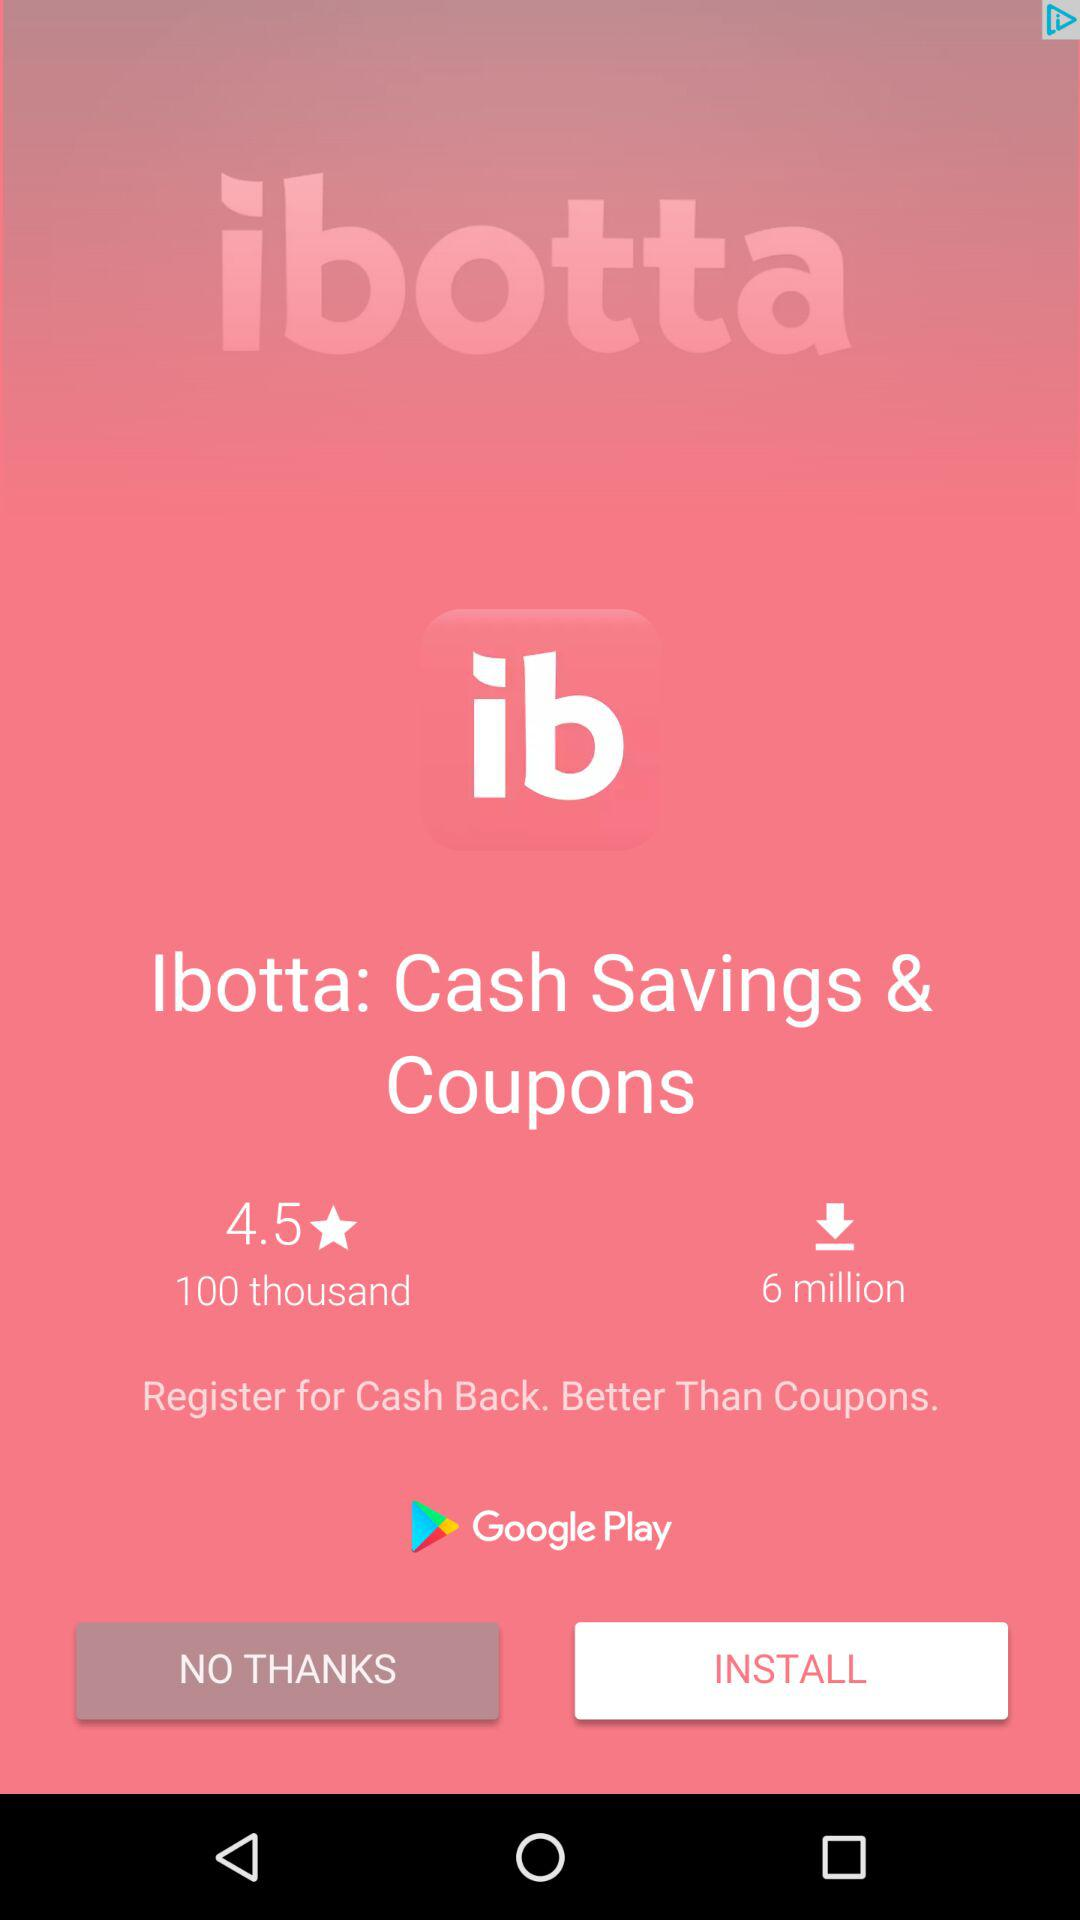How many more downloads does Ibotta have than reviews?
Answer the question using a single word or phrase. 5.9 million 